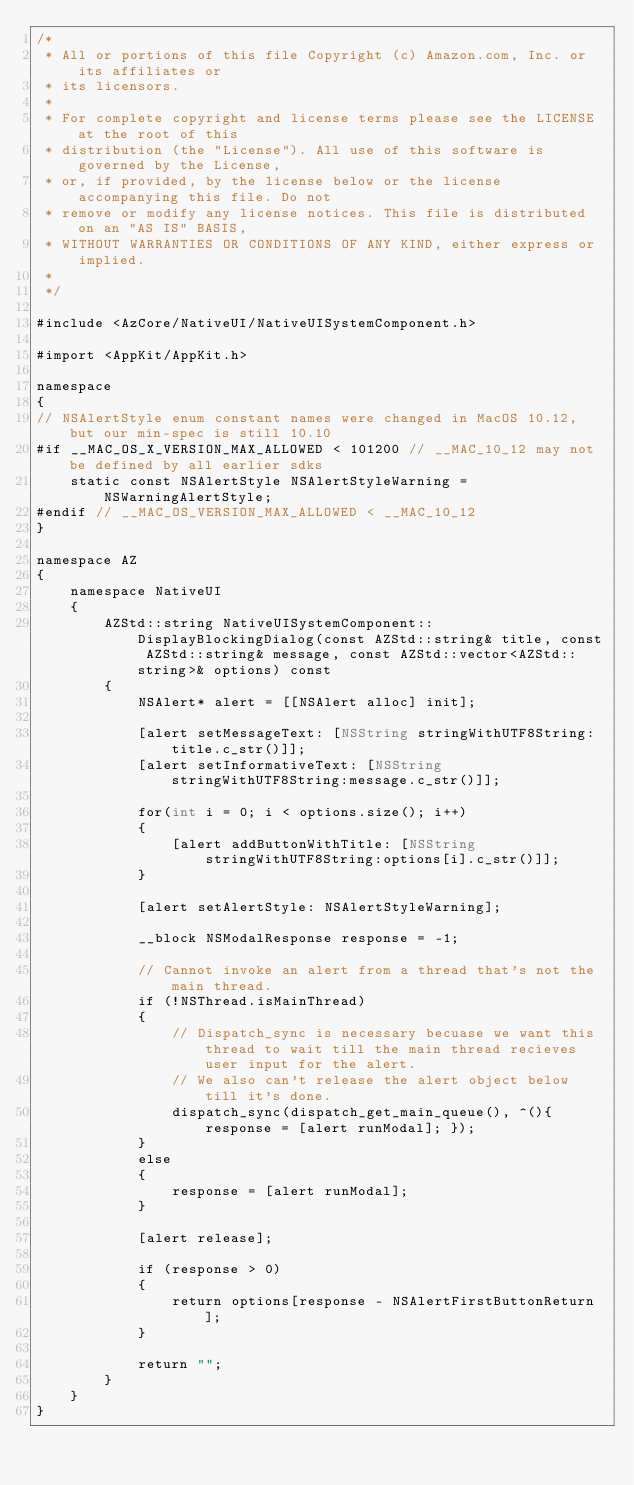Convert code to text. <code><loc_0><loc_0><loc_500><loc_500><_ObjectiveC_>/*
 * All or portions of this file Copyright (c) Amazon.com, Inc. or its affiliates or
 * its licensors.
 *
 * For complete copyright and license terms please see the LICENSE at the root of this
 * distribution (the "License"). All use of this software is governed by the License,
 * or, if provided, by the license below or the license accompanying this file. Do not
 * remove or modify any license notices. This file is distributed on an "AS IS" BASIS,
 * WITHOUT WARRANTIES OR CONDITIONS OF ANY KIND, either express or implied.
 *
 */

#include <AzCore/NativeUI/NativeUISystemComponent.h>

#import <AppKit/AppKit.h>

namespace
{
// NSAlertStyle enum constant names were changed in MacOS 10.12, but our min-spec is still 10.10
#if __MAC_OS_X_VERSION_MAX_ALLOWED < 101200 // __MAC_10_12 may not be defined by all earlier sdks
    static const NSAlertStyle NSAlertStyleWarning = NSWarningAlertStyle;
#endif // __MAC_OS_VERSION_MAX_ALLOWED < __MAC_10_12
}

namespace AZ
{
    namespace NativeUI
    {
        AZStd::string NativeUISystemComponent::DisplayBlockingDialog(const AZStd::string& title, const AZStd::string& message, const AZStd::vector<AZStd::string>& options) const
        {
            NSAlert* alert = [[NSAlert alloc] init];
            
            [alert setMessageText: [NSString stringWithUTF8String:title.c_str()]];
            [alert setInformativeText: [NSString stringWithUTF8String:message.c_str()]];
            
            for(int i = 0; i < options.size(); i++)
            {
                [alert addButtonWithTitle: [NSString stringWithUTF8String:options[i].c_str()]];
            }
            
            [alert setAlertStyle: NSAlertStyleWarning];
            
            __block NSModalResponse response = -1;
            
            // Cannot invoke an alert from a thread that's not the main thread.
            if (!NSThread.isMainThread)
            {
                // Dispatch_sync is necessary becuase we want this thread to wait till the main thread recieves user input for the alert.
                // We also can't release the alert object below till it's done.
                dispatch_sync(dispatch_get_main_queue(), ^(){ response = [alert runModal]; });
            }
            else
            {
                response = [alert runModal];
            }
            
            [alert release];
            
            if (response > 0)
            {
                return options[response - NSAlertFirstButtonReturn];
            }
            
            return "";
        }
    }
}
</code> 